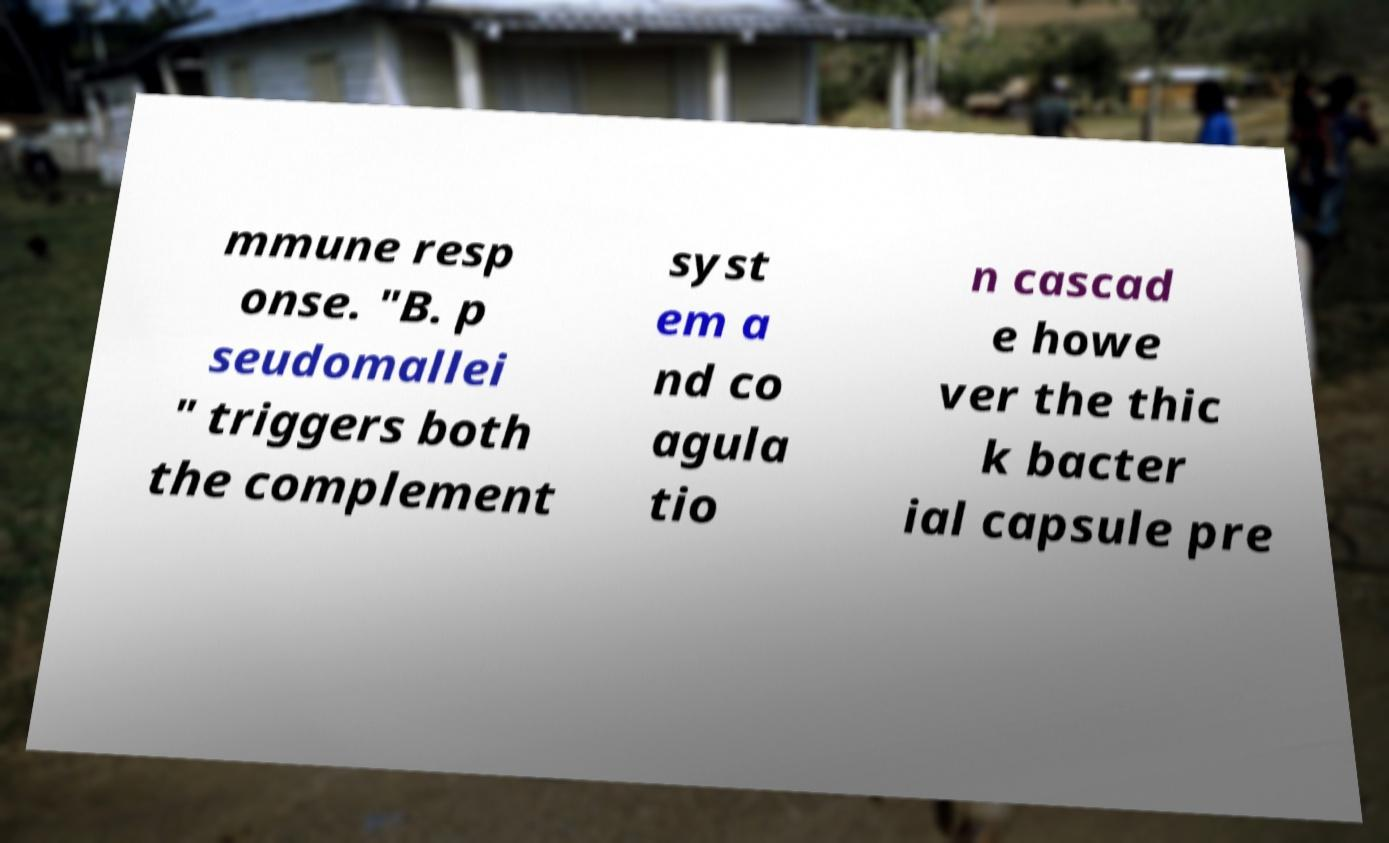Can you read and provide the text displayed in the image?This photo seems to have some interesting text. Can you extract and type it out for me? mmune resp onse. "B. p seudomallei " triggers both the complement syst em a nd co agula tio n cascad e howe ver the thic k bacter ial capsule pre 